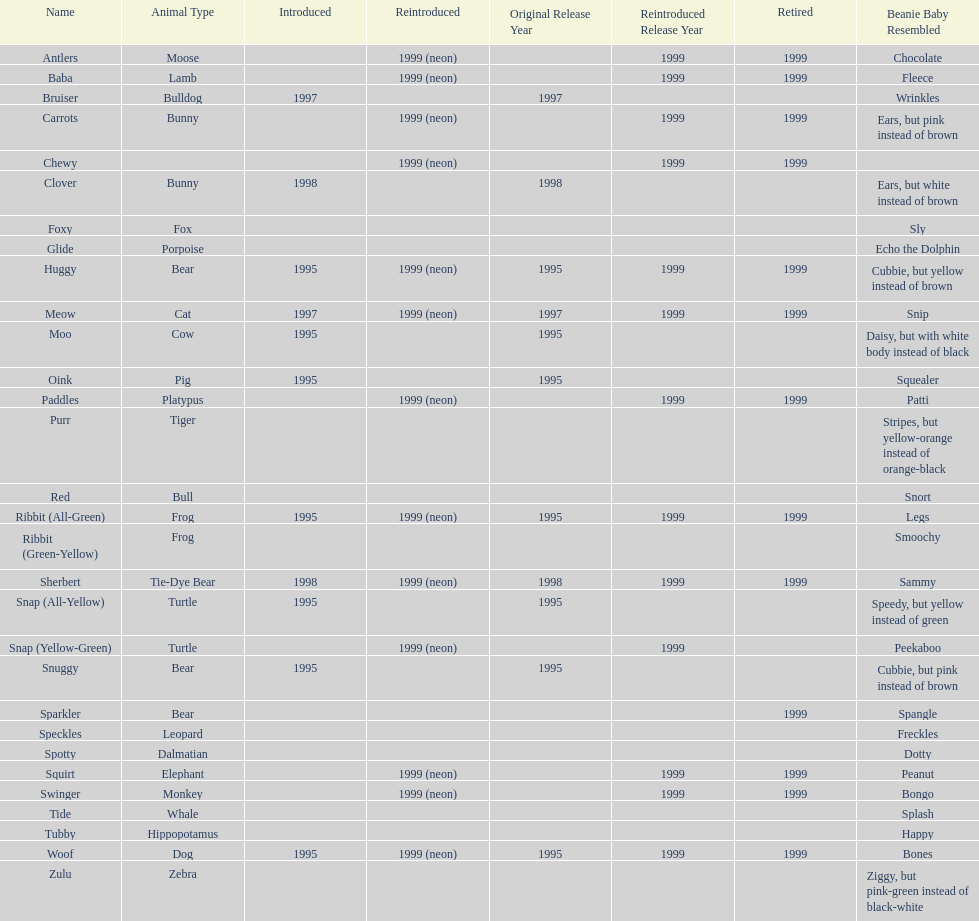How many monkey pillow pals were there? 1. 